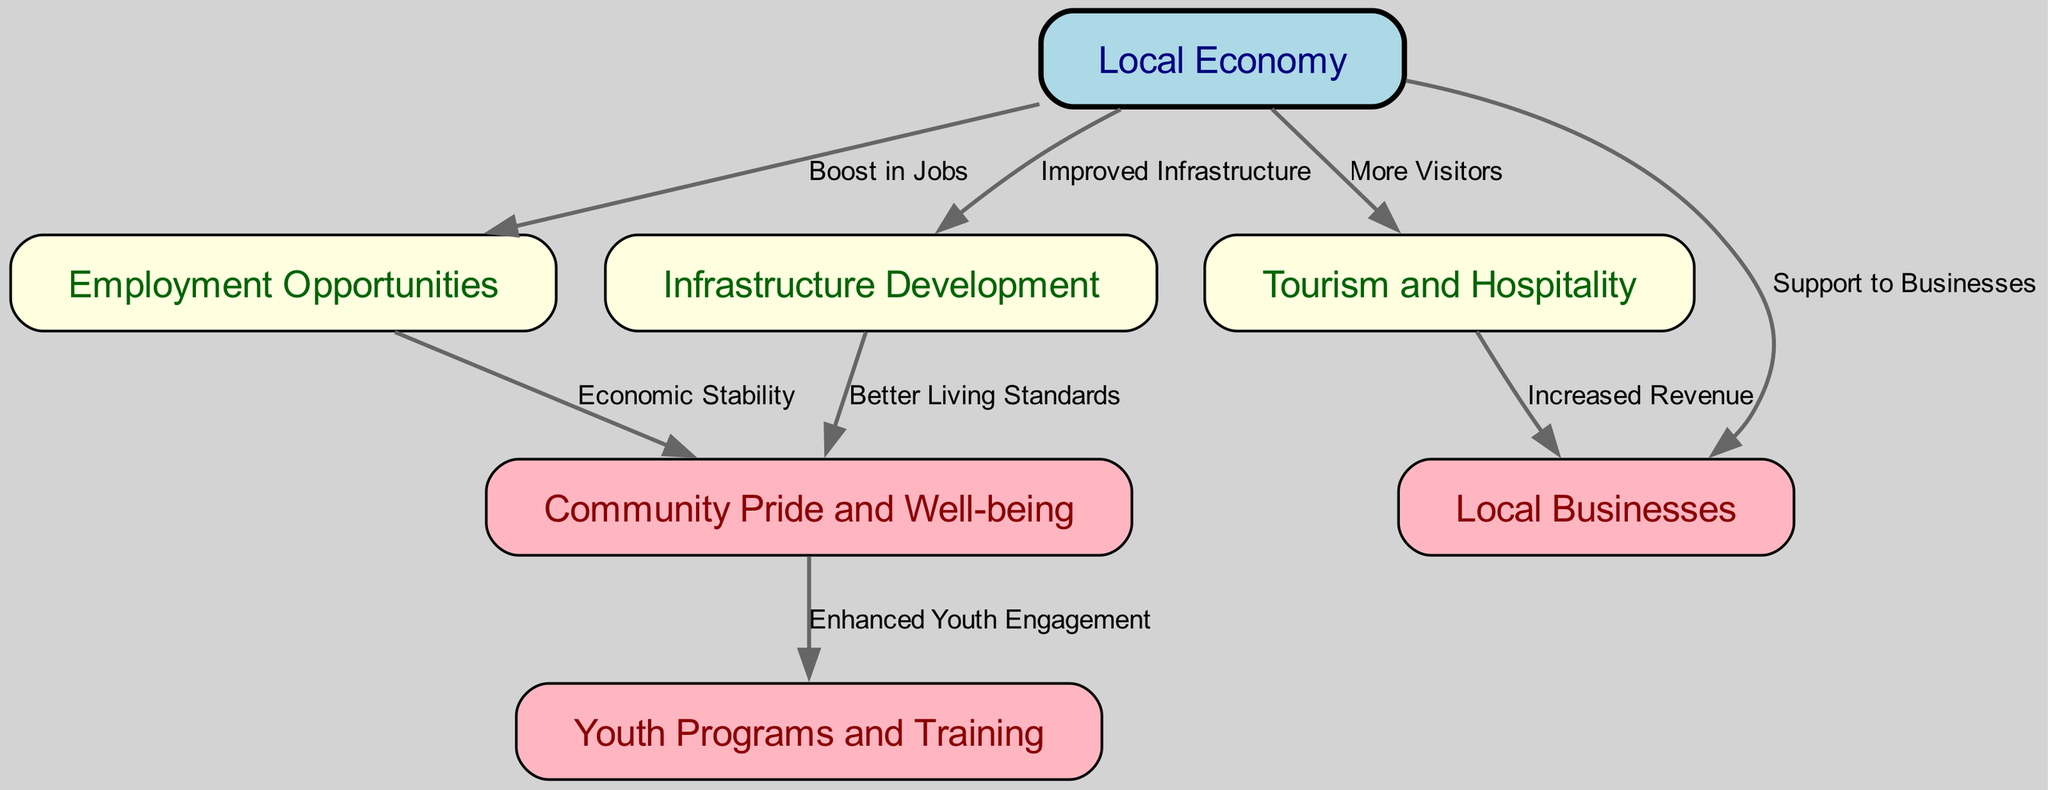What is the primary node that connects all other nodes? The primary node is "Local Economy," as it serves as the central hub connecting multiple outcomes like employment, infrastructure, tourism, and local businesses.
Answer: Local Economy How many nodes are present in this diagram? The diagram contains a total of 7 nodes, each representing different aspects of the socioeconomic impact of the franchise.
Answer: 7 Which node indicates the potential for job creation? The node "Employment Opportunities" is directly linked to "Local Economy," signifying job creation as an outcome of the franchise's impact.
Answer: Employment Opportunities What relationship exists between "Community Pride" and "Youth Programs"? The diagram shows an edge labeled "Enhanced Youth Engagement" connecting "Community Pride" to "Youth Programs," indicating a positive impact.
Answer: Enhanced Youth Engagement How does "Tourism" affect "Local Businesses"? The influence is represented by the edge labeled "Increased Revenue," demonstrating that tourism can enhance the financial performance of local businesses.
Answer: Increased Revenue What impact does "Infrastructure Development" have on "Community Pride"? The diagram illustrates that better infrastructure improves living standards, indicated by the edge labeled "Better Living Standards" connecting to "Community Pride."
Answer: Better Living Standards If "Local Economy" sees growth, what is a direct effect on "Employment Opportunities"? The diagram indicates that a boost in jobs is a direct effect of the growth in the local economy, as represented by the edge connecting the two.
Answer: Boost in Jobs How does "Tourism and Hospitality" contribute to the local economy? The contribution is shown through the edge labeled "More Visitors," which signifies that tourism draws more people, thus supporting economic growth.
Answer: More Visitors Which node represents initiatives aimed at the younger population? The "Youth Programs and Training" node is dedicated to initiatives focusing on young individuals, showcasing the franchise's investment in future talent.
Answer: Youth Programs and Training 